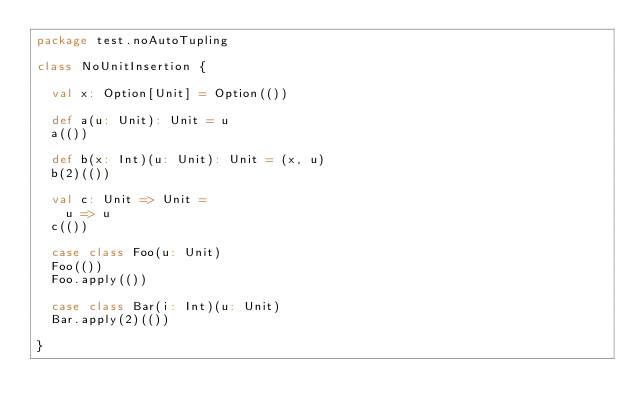<code> <loc_0><loc_0><loc_500><loc_500><_Scala_>package test.noAutoTupling

class NoUnitInsertion {

  val x: Option[Unit] = Option(())

  def a(u: Unit): Unit = u
  a(())

  def b(x: Int)(u: Unit): Unit = (x, u)
  b(2)(())

  val c: Unit => Unit =
    u => u
  c(())

  case class Foo(u: Unit)
  Foo(())
  Foo.apply(())

  case class Bar(i: Int)(u: Unit)
  Bar.apply(2)(())

}</code> 